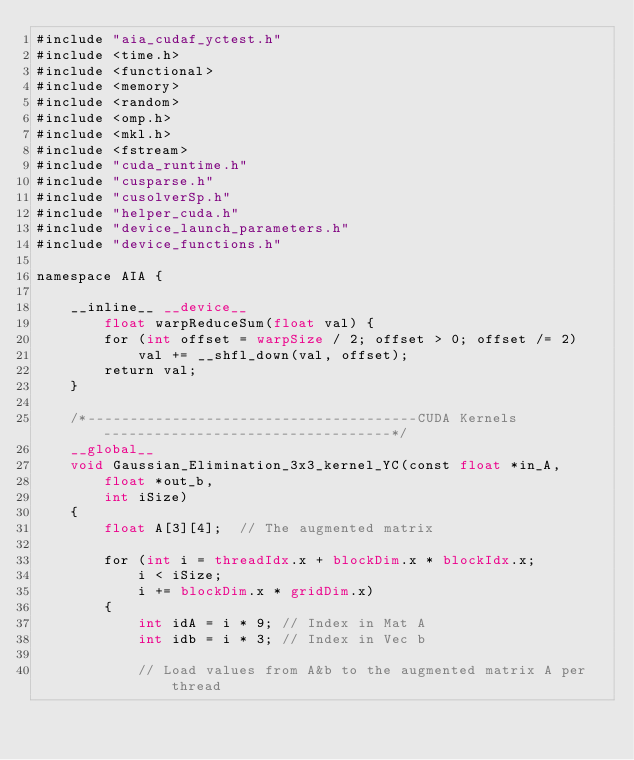<code> <loc_0><loc_0><loc_500><loc_500><_Cuda_>#include "aia_cudaf_yctest.h"
#include <time.h>
#include <functional>
#include <memory>
#include <random>
#include <omp.h>
#include <mkl.h>
#include <fstream>
#include "cuda_runtime.h"
#include "cusparse.h"
#include "cusolverSp.h"
#include "helper_cuda.h"
#include "device_launch_parameters.h"
#include "device_functions.h"

namespace AIA {

	__inline__ __device__
		float warpReduceSum(float val) {
		for (int offset = warpSize / 2; offset > 0; offset /= 2)
			val += __shfl_down(val, offset);
		return val;
	}

	/*---------------------------------------CUDA Kernels----------------------------------*/
	__global__
	void Gaussian_Elimination_3x3_kernel_YC(const float *in_A,
		float *out_b,
		int iSize)
	{
		float A[3][4];	// The augmented matrix

		for (int i = threadIdx.x + blockDim.x * blockIdx.x;
			i < iSize;
			i += blockDim.x * gridDim.x)
		{
			int idA = i * 9; // Index in Mat A
			int idb = i * 3; // Index in Vec b

			// Load values from A&b to the augmented matrix A per thread</code> 